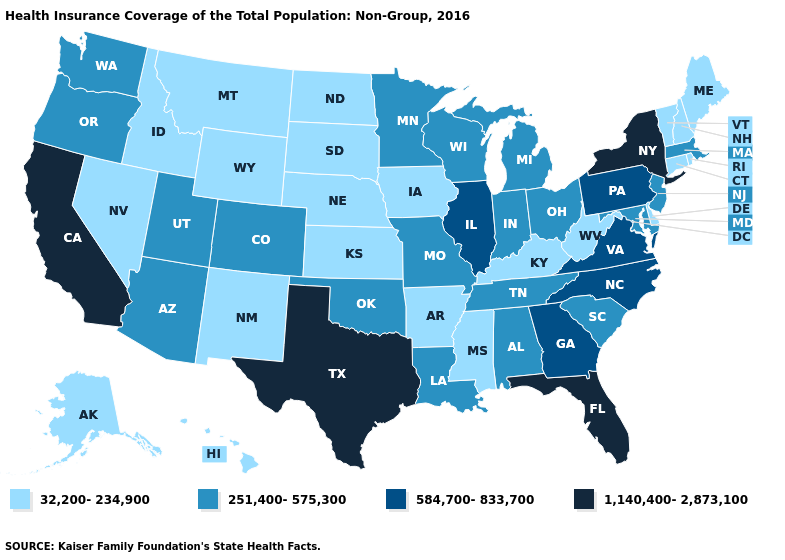Which states have the highest value in the USA?
Short answer required. California, Florida, New York, Texas. Is the legend a continuous bar?
Be succinct. No. Name the states that have a value in the range 1,140,400-2,873,100?
Short answer required. California, Florida, New York, Texas. Does the first symbol in the legend represent the smallest category?
Write a very short answer. Yes. Name the states that have a value in the range 1,140,400-2,873,100?
Concise answer only. California, Florida, New York, Texas. What is the lowest value in the West?
Answer briefly. 32,200-234,900. What is the lowest value in states that border Wisconsin?
Answer briefly. 32,200-234,900. What is the value of Florida?
Write a very short answer. 1,140,400-2,873,100. Does the map have missing data?
Give a very brief answer. No. What is the value of Georgia?
Quick response, please. 584,700-833,700. What is the lowest value in states that border Washington?
Concise answer only. 32,200-234,900. Name the states that have a value in the range 1,140,400-2,873,100?
Short answer required. California, Florida, New York, Texas. Name the states that have a value in the range 32,200-234,900?
Answer briefly. Alaska, Arkansas, Connecticut, Delaware, Hawaii, Idaho, Iowa, Kansas, Kentucky, Maine, Mississippi, Montana, Nebraska, Nevada, New Hampshire, New Mexico, North Dakota, Rhode Island, South Dakota, Vermont, West Virginia, Wyoming. How many symbols are there in the legend?
Quick response, please. 4. What is the value of Colorado?
Write a very short answer. 251,400-575,300. 